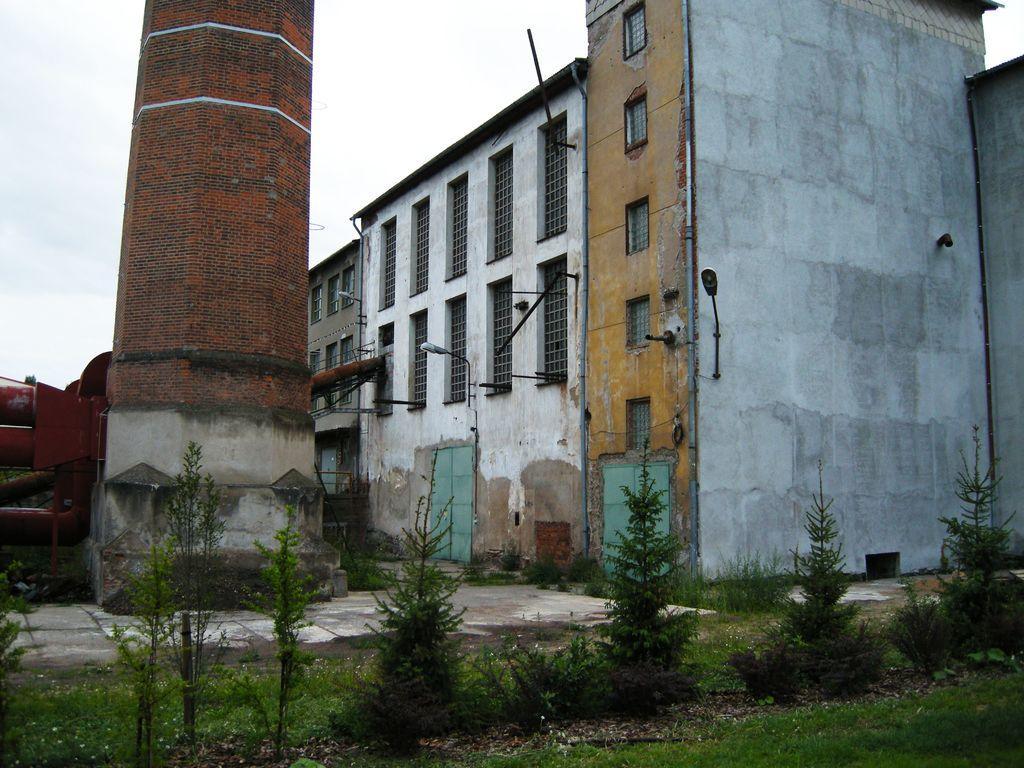In one or two sentences, can you explain what this image depicts? In this image we can see buildings, there are some lights, plants, grass, windows, poles and a tower, in the background we can see the sky. 